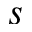<formula> <loc_0><loc_0><loc_500><loc_500>s</formula> 